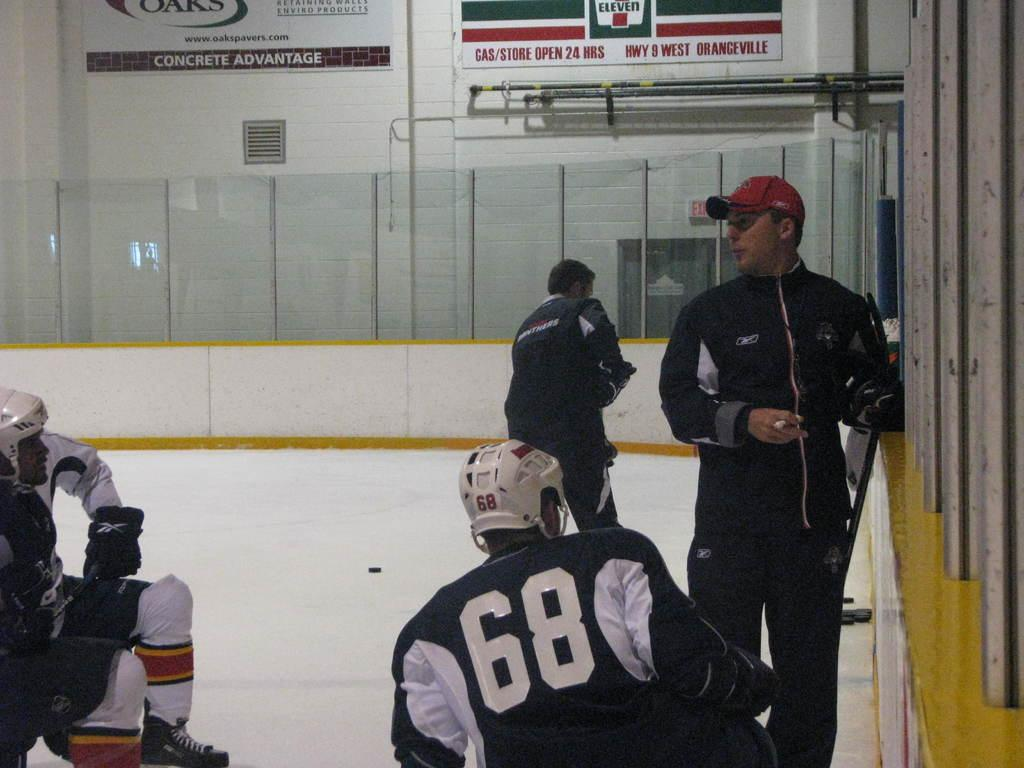<image>
Relay a brief, clear account of the picture shown. A hockey player with 68 on the back of his uniform kneels in front of a 7 Eleven sign on the wall. 